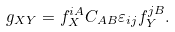Convert formula to latex. <formula><loc_0><loc_0><loc_500><loc_500>g _ { X Y } = f _ { X } ^ { i A } C _ { A B } \varepsilon _ { i j } f _ { Y } ^ { j B } .</formula> 